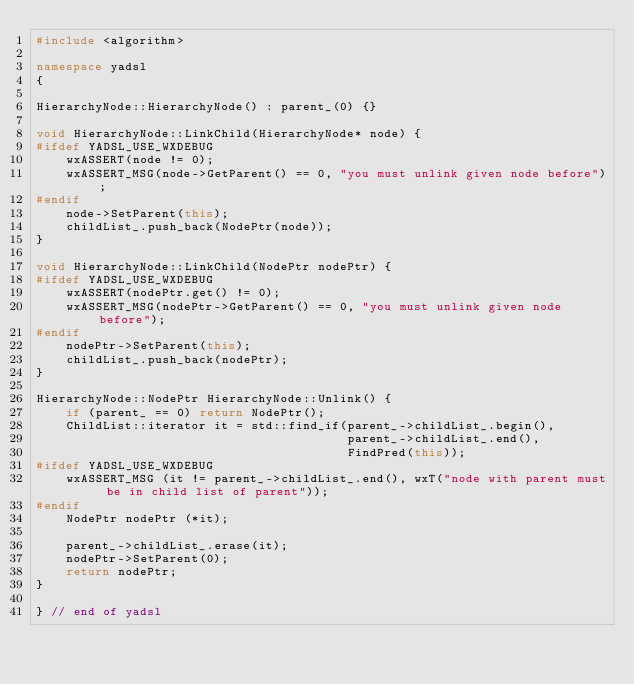<code> <loc_0><loc_0><loc_500><loc_500><_C++_>#include <algorithm>

namespace yadsl
{

HierarchyNode::HierarchyNode() : parent_(0) {}

void HierarchyNode::LinkChild(HierarchyNode* node) {
#ifdef YADSL_USE_WXDEBUG
    wxASSERT(node != 0);
    wxASSERT_MSG(node->GetParent() == 0, "you must unlink given node before");
#endif
    node->SetParent(this);
    childList_.push_back(NodePtr(node));
}

void HierarchyNode::LinkChild(NodePtr nodePtr) {
#ifdef YADSL_USE_WXDEBUG
    wxASSERT(nodePtr.get() != 0);
    wxASSERT_MSG(nodePtr->GetParent() == 0, "you must unlink given node before");
#endif
    nodePtr->SetParent(this);
    childList_.push_back(nodePtr);
}

HierarchyNode::NodePtr HierarchyNode::Unlink() {
    if (parent_ == 0) return NodePtr();
    ChildList::iterator it = std::find_if(parent_->childList_.begin(),
                                          parent_->childList_.end(),
                                          FindPred(this));
#ifdef YADSL_USE_WXDEBUG
    wxASSERT_MSG (it != parent_->childList_.end(), wxT("node with parent must be in child list of parent"));
#endif
    NodePtr nodePtr (*it);

    parent_->childList_.erase(it);
    nodePtr->SetParent(0);
    return nodePtr;
}

} // end of yadsl
</code> 